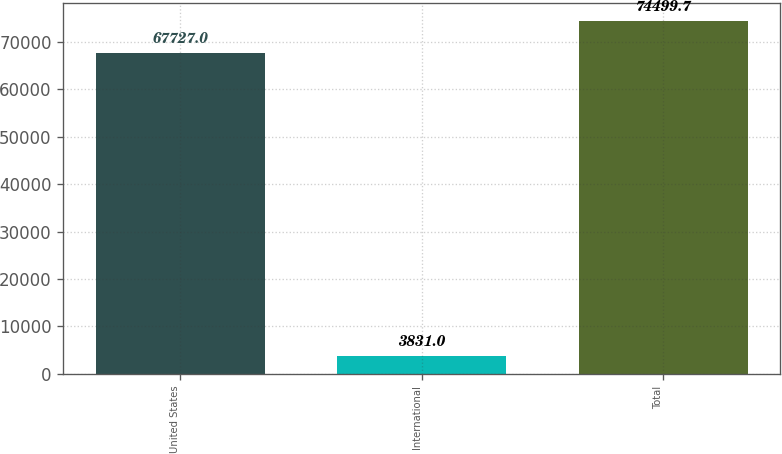Convert chart to OTSL. <chart><loc_0><loc_0><loc_500><loc_500><bar_chart><fcel>United States<fcel>International<fcel>Total<nl><fcel>67727<fcel>3831<fcel>74499.7<nl></chart> 